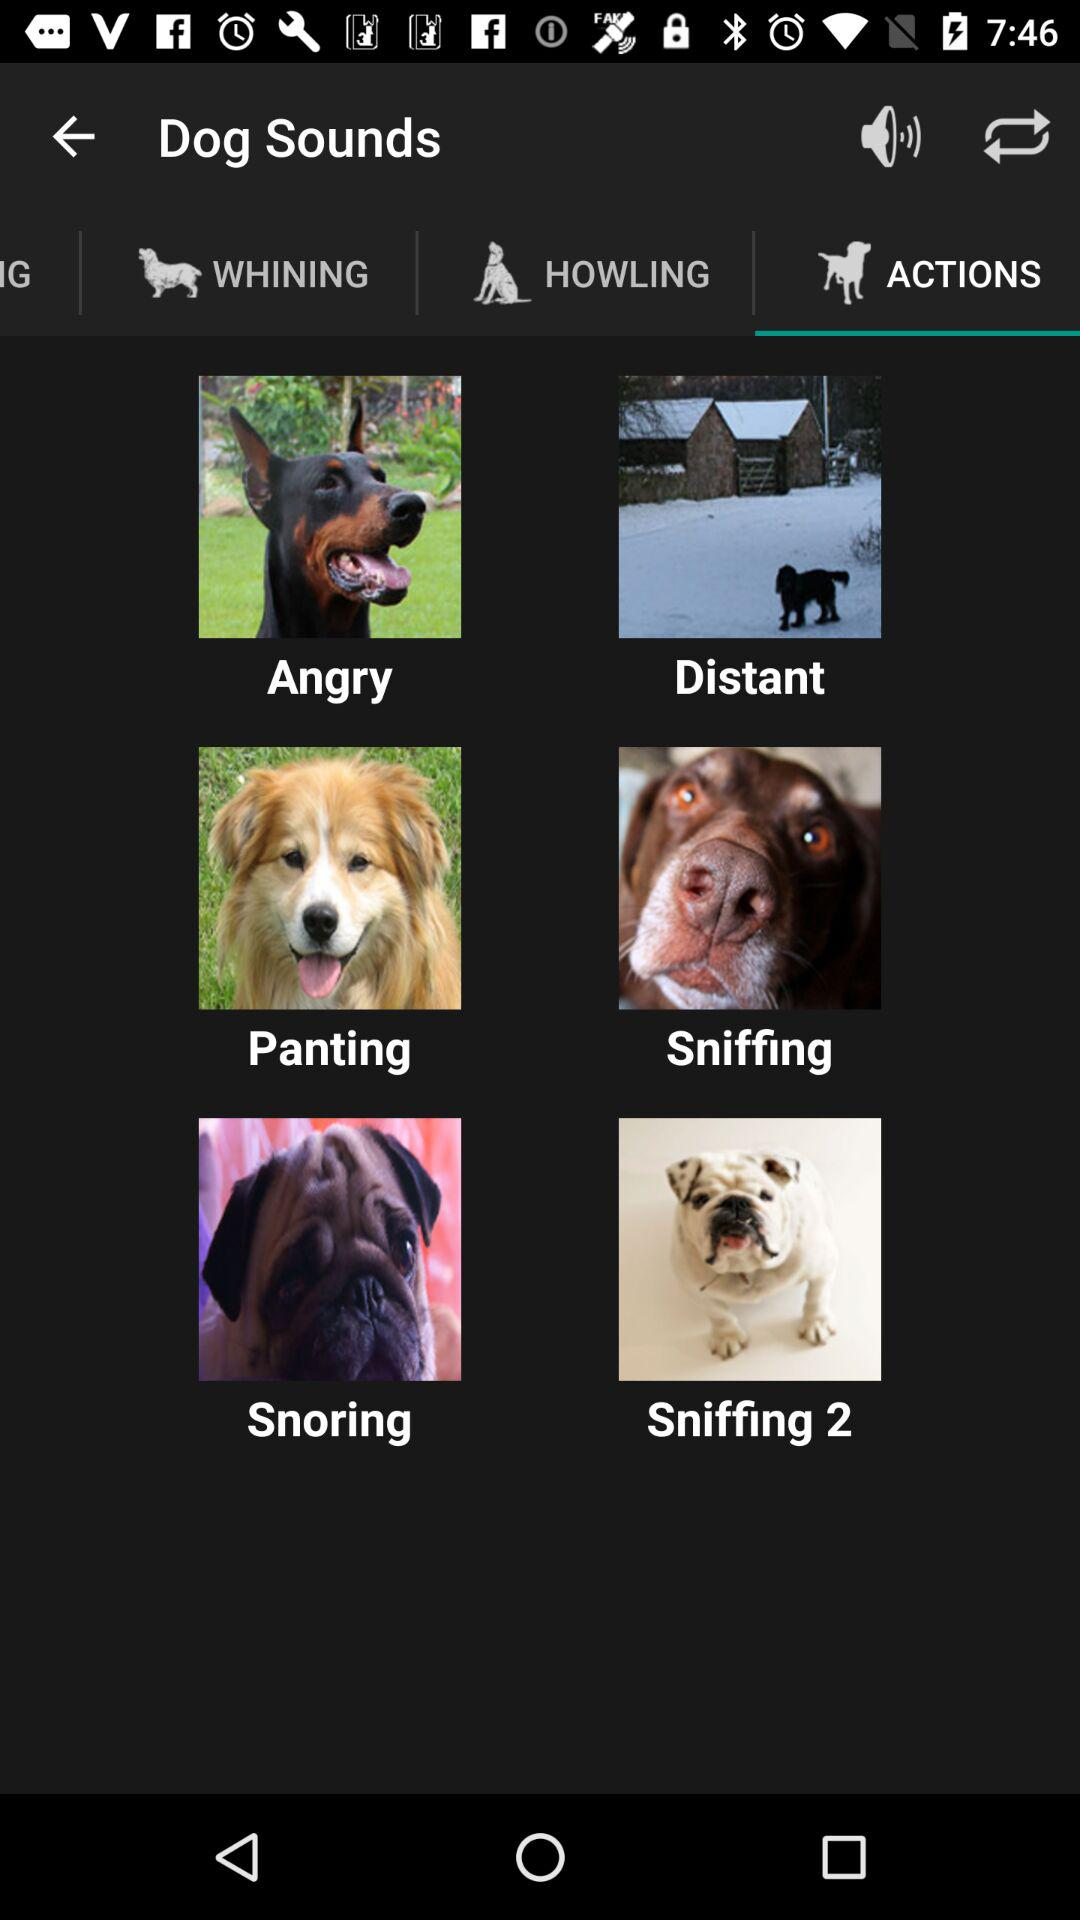What is the application name?
When the provided information is insufficient, respond with <no answer>. <no answer> 